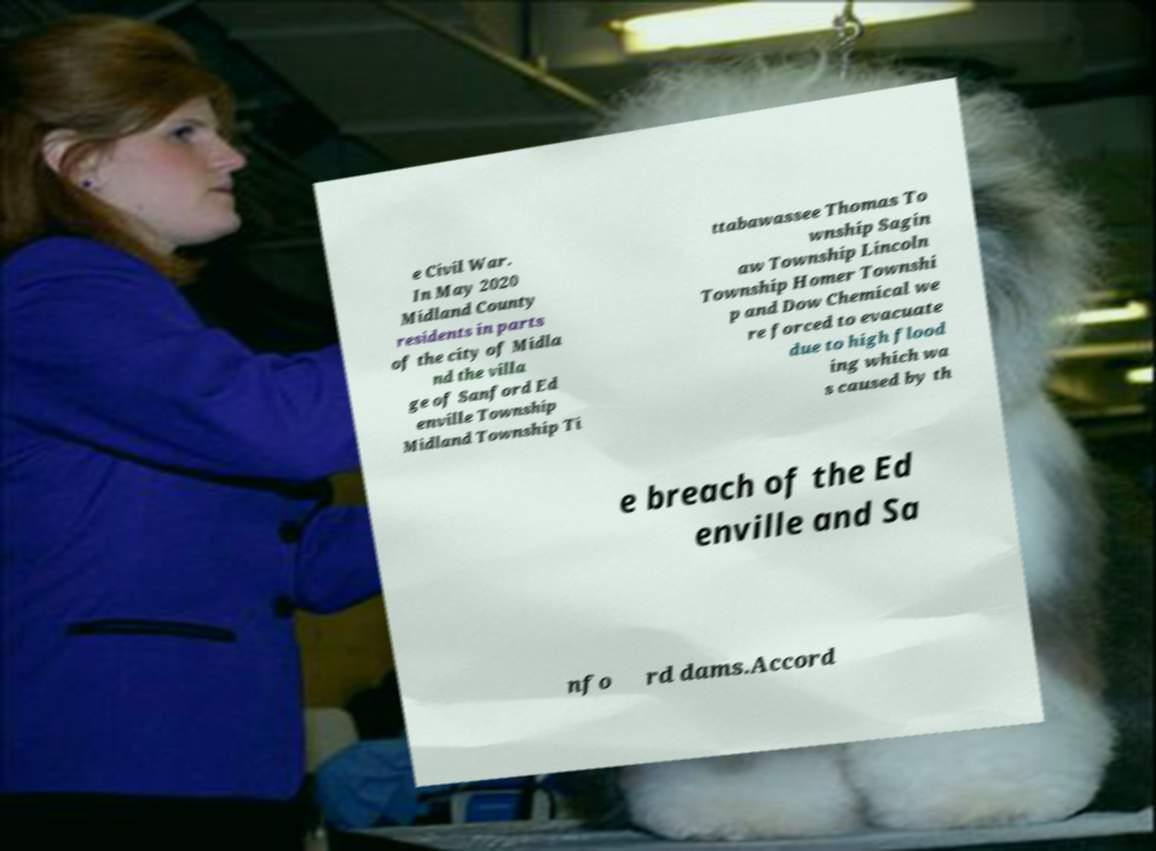What messages or text are displayed in this image? I need them in a readable, typed format. e Civil War. In May 2020 Midland County residents in parts of the city of Midla nd the villa ge of Sanford Ed enville Township Midland Township Ti ttabawassee Thomas To wnship Sagin aw Township Lincoln Township Homer Townshi p and Dow Chemical we re forced to evacuate due to high flood ing which wa s caused by th e breach of the Ed enville and Sa nfo rd dams.Accord 